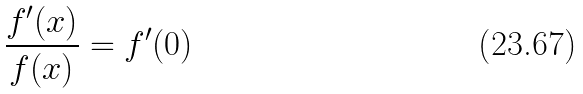Convert formula to latex. <formula><loc_0><loc_0><loc_500><loc_500>\frac { f ^ { \prime } ( x ) } { f ( x ) } = f ^ { \prime } ( 0 )</formula> 